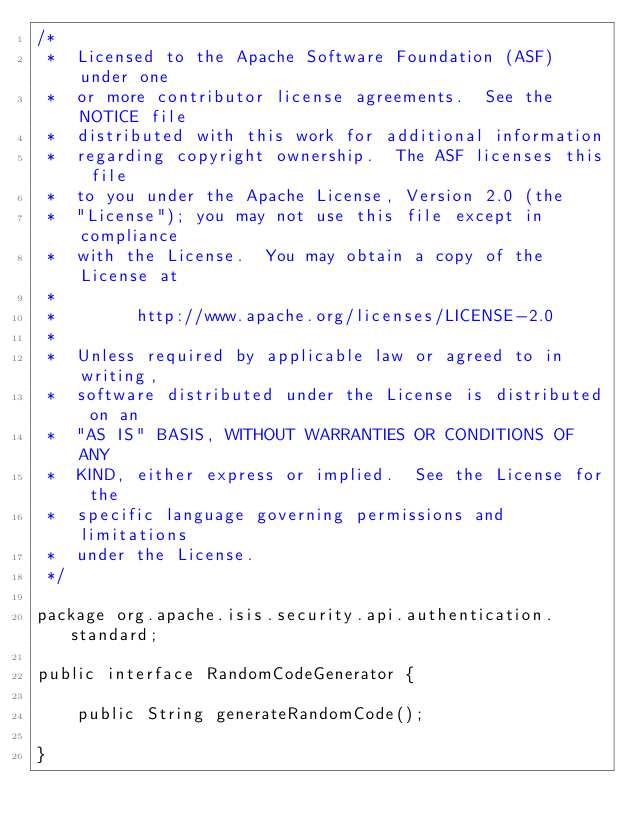<code> <loc_0><loc_0><loc_500><loc_500><_Java_>/*
 *  Licensed to the Apache Software Foundation (ASF) under one
 *  or more contributor license agreements.  See the NOTICE file
 *  distributed with this work for additional information
 *  regarding copyright ownership.  The ASF licenses this file
 *  to you under the Apache License, Version 2.0 (the
 *  "License"); you may not use this file except in compliance
 *  with the License.  You may obtain a copy of the License at
 *
 *        http://www.apache.org/licenses/LICENSE-2.0
 *
 *  Unless required by applicable law or agreed to in writing,
 *  software distributed under the License is distributed on an
 *  "AS IS" BASIS, WITHOUT WARRANTIES OR CONDITIONS OF ANY
 *  KIND, either express or implied.  See the License for the
 *  specific language governing permissions and limitations
 *  under the License.
 */

package org.apache.isis.security.api.authentication.standard;

public interface RandomCodeGenerator {

    public String generateRandomCode();

}
</code> 